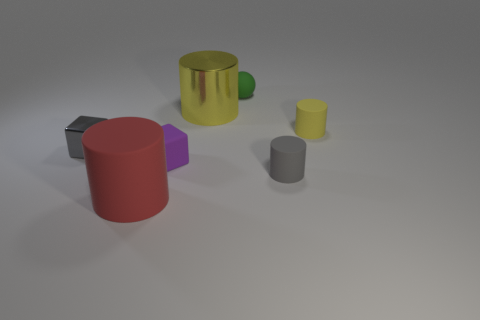Add 3 big yellow metal things. How many objects exist? 10 Subtract all blocks. How many objects are left? 5 Add 6 gray metallic blocks. How many gray metallic blocks exist? 7 Subtract 0 gray balls. How many objects are left? 7 Subtract all brown rubber cubes. Subtract all red rubber things. How many objects are left? 6 Add 7 rubber cylinders. How many rubber cylinders are left? 10 